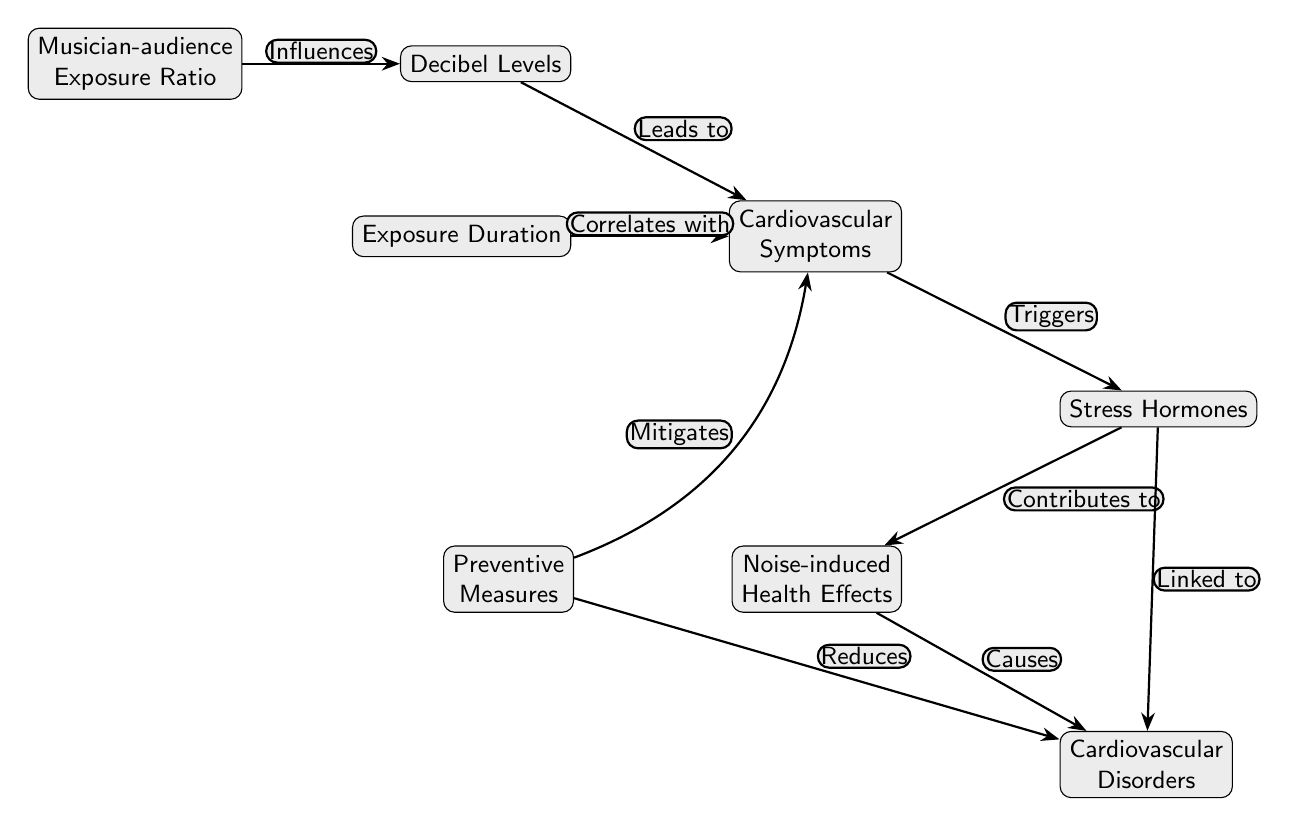What are the two main factors influencing cardiovascular symptoms? The diagram shows that "Decibel Levels" and "Exposure Duration" are both connected to the node "Cardiovascular Symptoms" through arrows indicating influence.
Answer: Decibel Levels, Exposure Duration How many nodes are in the diagram? Counting all visible boxes representing nodes, we find a total of 8 distinct nodes, each representing a concept related to cardiovascular health in musicians exposed to loud music.
Answer: 8 What does the "Preventive Measures" node do to cardiovascular symptoms? The diagram indicates that "Preventive Measures" has an arrow pointing to "Cardiovascular Symptoms" labeled "Mitigates," suggesting that these measures help reduce the symptoms.
Answer: Mitigates Which node is linked to both "Stress Hormones" and "Cardiovascular Disorders"? Reviewing the connections in the diagram, "Stress Hormones" has outgoing edges connecting to both "Noise-induced Health Effects" and "Cardiovascular Disorders," indicating its relevance to both.
Answer: Cardiovascular Disorders What does the "Noise-induced Health Effects" node cause? The arrow from "Noise-induced Health Effects" points to "Cardiovascular Disorders" with the label "Causes," indicating a direct causal relationship to cardiovascular health issues.
Answer: Cardiovascular Disorders What connection do "Musician-audience Exposure Ratio" and "Decibel Levels" share? The connection is labeled "Influences," which shows that the "Musician-audience Exposure Ratio" has a determining effect on the "Decibel Levels" experienced by musicians.
Answer: Influences Which node contributes to "Noise-induced Health Effects"? The diagram shows an arrow from "Stress Hormones" to "Noise-induced Health Effects" labeled "Contributes," indicating that stress hormones play a role in exacerbating health effects due to noise.
Answer: Stress Hormones What effect do "Preventive Measures" have on cardiovascular disorders? The arrow from "Preventive Measures" to "Cardiovascular Disorders" is labeled "Reduces," showing that implementing preventive strategies can decrease the incidence of these disorders.
Answer: Reduces 